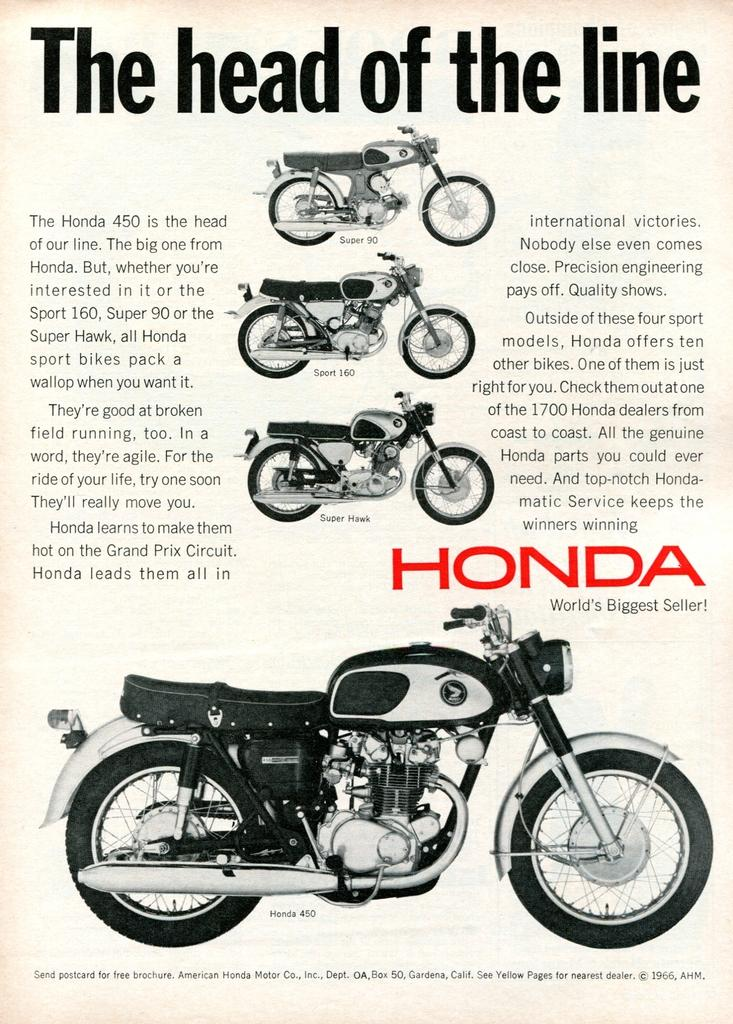What type of vehicles are in the image? There are bikes in the image. Where can text be found in the image? There is text on the left side and the right side of the image. What type of office equipment can be seen in the image? There is no office equipment present in the image; it features bikes and text. What type of coil is visible in the image? There is no coil present in the image. 